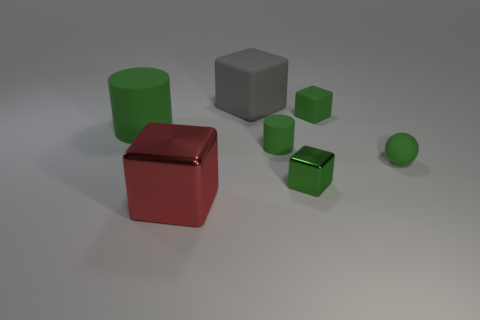Subtract all tiny rubber blocks. How many blocks are left? 3 Subtract all balls. How many objects are left? 6 Subtract all red blocks. How many blocks are left? 3 Add 7 green cubes. How many green cubes exist? 9 Add 1 gray blocks. How many objects exist? 8 Subtract 0 red cylinders. How many objects are left? 7 Subtract 1 spheres. How many spheres are left? 0 Subtract all blue balls. Subtract all gray blocks. How many balls are left? 1 Subtract all cyan balls. How many blue cylinders are left? 0 Subtract all tiny cylinders. Subtract all red blocks. How many objects are left? 5 